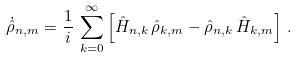Convert formula to latex. <formula><loc_0><loc_0><loc_500><loc_500>\dot { \hat { \rho } } _ { n , m } = \frac { 1 } { i } \, \sum _ { k = 0 } ^ { \infty } \left [ \hat { H } _ { n , k } \, \hat { \rho } _ { k , m } - \hat { \rho } _ { n , k } \, \hat { H } _ { k , m } \right ] \, .</formula> 